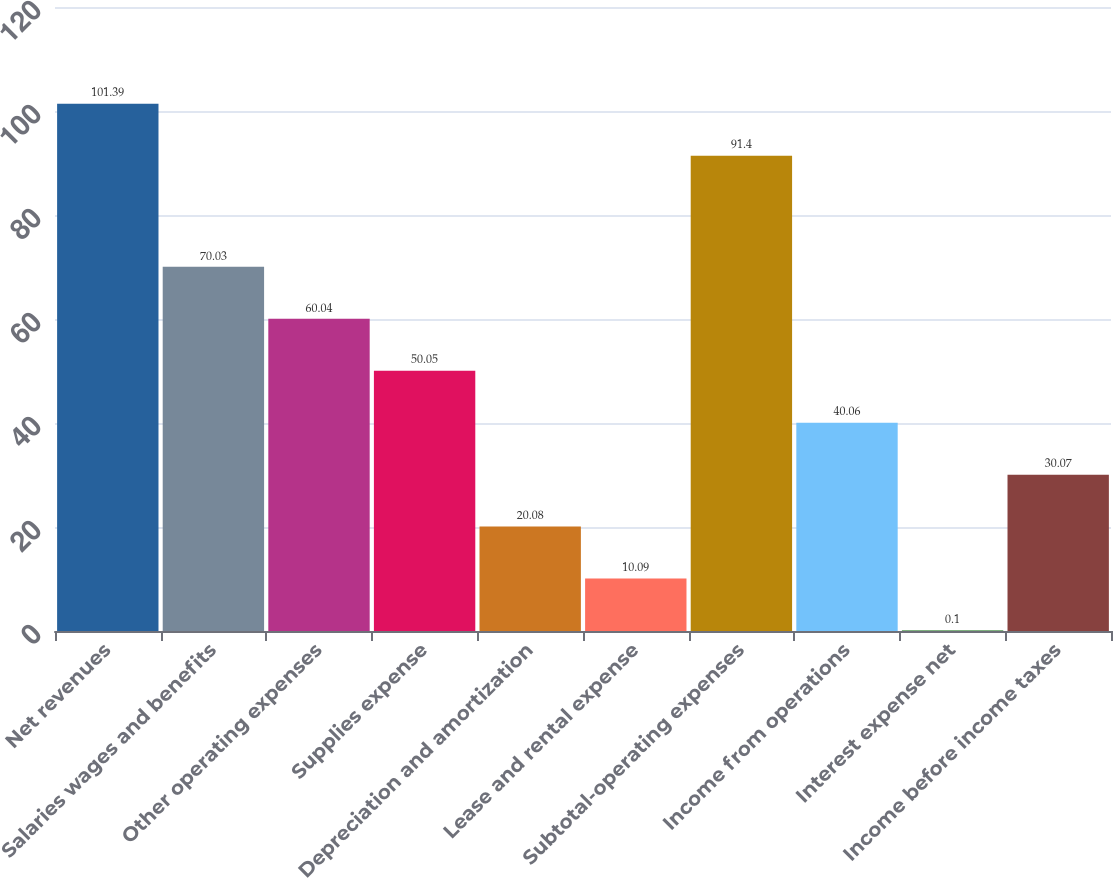Convert chart. <chart><loc_0><loc_0><loc_500><loc_500><bar_chart><fcel>Net revenues<fcel>Salaries wages and benefits<fcel>Other operating expenses<fcel>Supplies expense<fcel>Depreciation and amortization<fcel>Lease and rental expense<fcel>Subtotal-operating expenses<fcel>Income from operations<fcel>Interest expense net<fcel>Income before income taxes<nl><fcel>101.39<fcel>70.03<fcel>60.04<fcel>50.05<fcel>20.08<fcel>10.09<fcel>91.4<fcel>40.06<fcel>0.1<fcel>30.07<nl></chart> 